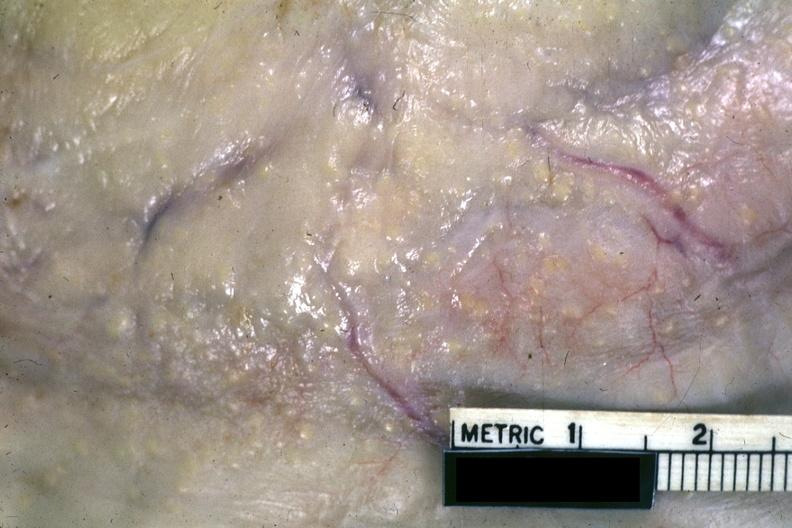s tuberculous peritonitis present?
Answer the question using a single word or phrase. Yes 